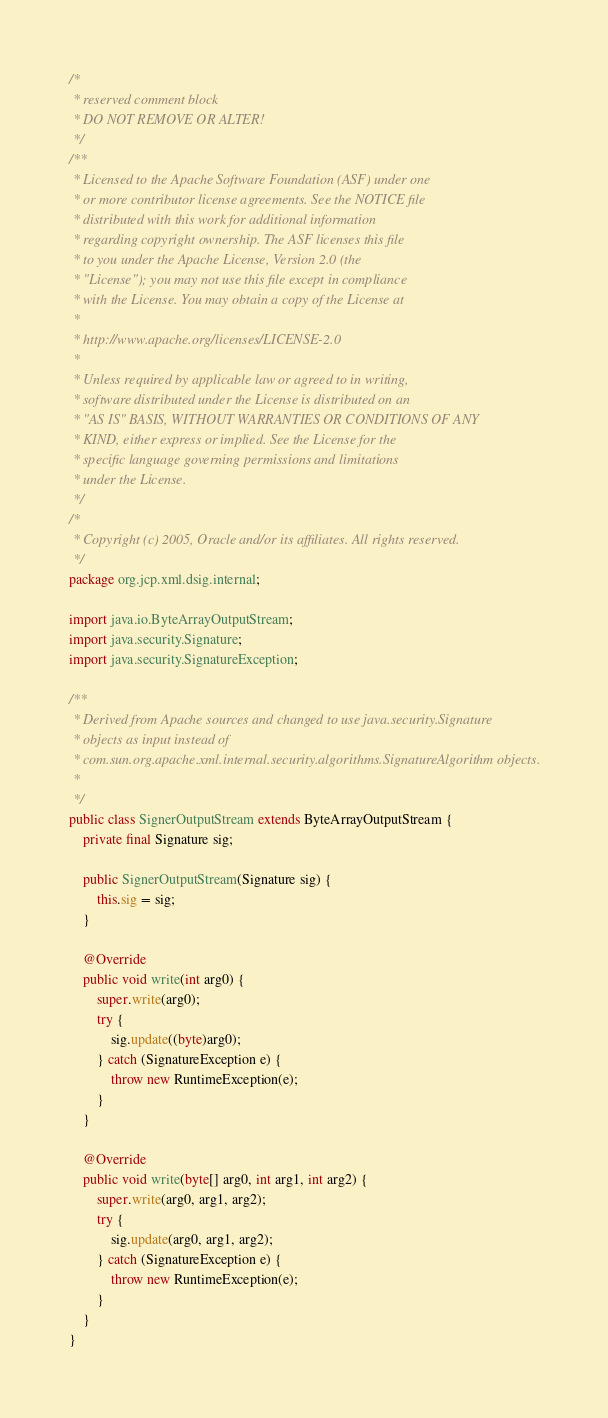Convert code to text. <code><loc_0><loc_0><loc_500><loc_500><_Java_>/*
 * reserved comment block
 * DO NOT REMOVE OR ALTER!
 */
/**
 * Licensed to the Apache Software Foundation (ASF) under one
 * or more contributor license agreements. See the NOTICE file
 * distributed with this work for additional information
 * regarding copyright ownership. The ASF licenses this file
 * to you under the Apache License, Version 2.0 (the
 * "License"); you may not use this file except in compliance
 * with the License. You may obtain a copy of the License at
 *
 * http://www.apache.org/licenses/LICENSE-2.0
 *
 * Unless required by applicable law or agreed to in writing,
 * software distributed under the License is distributed on an
 * "AS IS" BASIS, WITHOUT WARRANTIES OR CONDITIONS OF ANY
 * KIND, either express or implied. See the License for the
 * specific language governing permissions and limitations
 * under the License.
 */
/*
 * Copyright (c) 2005, Oracle and/or its affiliates. All rights reserved.
 */
package org.jcp.xml.dsig.internal;

import java.io.ByteArrayOutputStream;
import java.security.Signature;
import java.security.SignatureException;

/**
 * Derived from Apache sources and changed to use java.security.Signature
 * objects as input instead of
 * com.sun.org.apache.xml.internal.security.algorithms.SignatureAlgorithm objects.
 *
 */
public class SignerOutputStream extends ByteArrayOutputStream {
    private final Signature sig;

    public SignerOutputStream(Signature sig) {
        this.sig = sig;
    }

    @Override
    public void write(int arg0) {
        super.write(arg0);
        try {
            sig.update((byte)arg0);
        } catch (SignatureException e) {
            throw new RuntimeException(e);
        }
    }

    @Override
    public void write(byte[] arg0, int arg1, int arg2) {
        super.write(arg0, arg1, arg2);
        try {
            sig.update(arg0, arg1, arg2);
        } catch (SignatureException e) {
            throw new RuntimeException(e);
        }
    }
}
</code> 